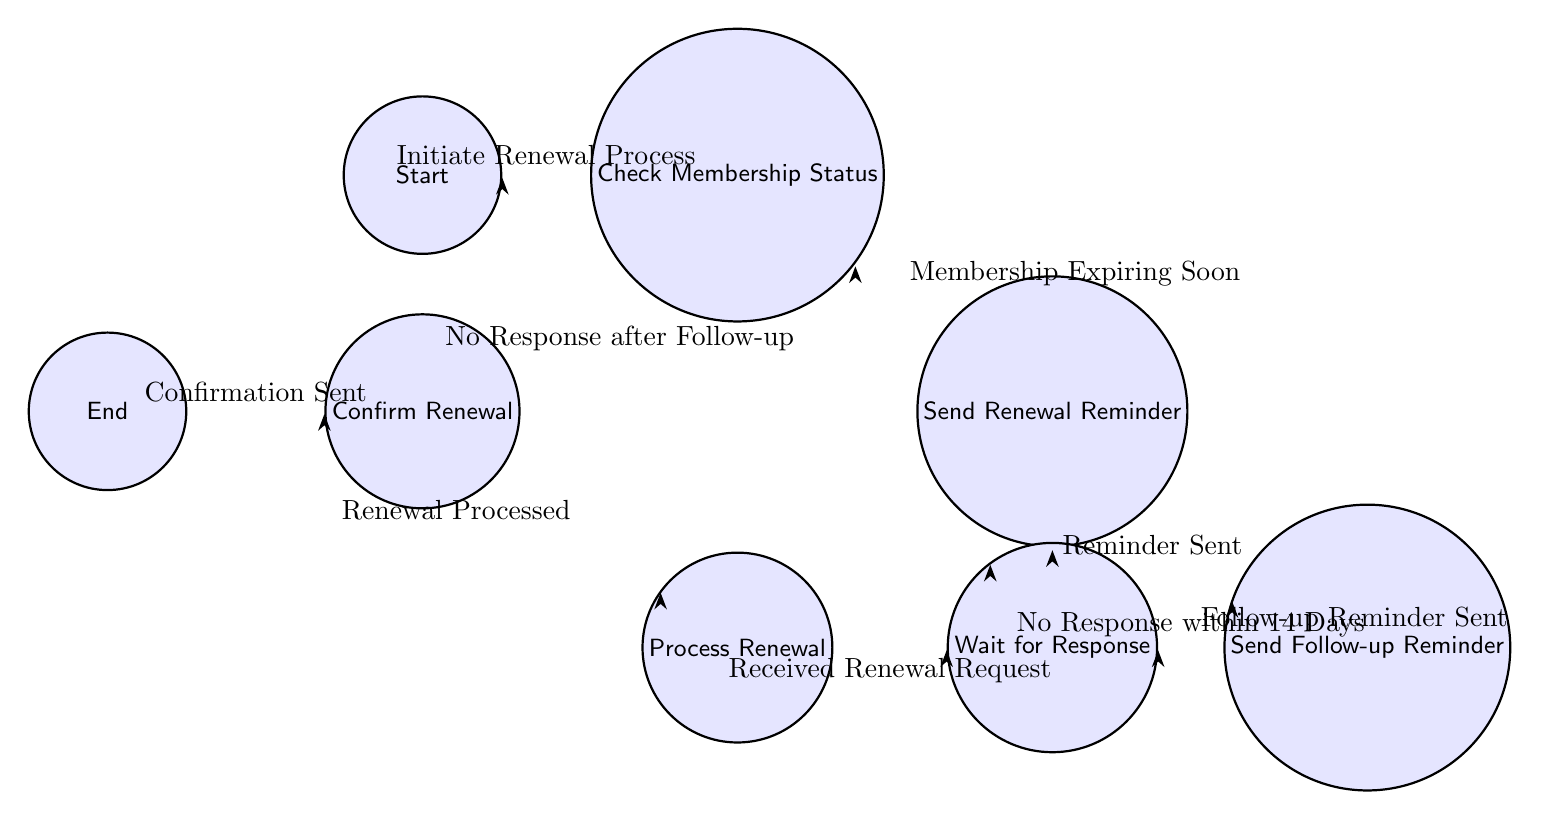What is the initial state of the membership renewal process? The initial state, represented by the first node in the diagram, is labeled “Start.”
Answer: Start How many states are present in the diagram? The diagram lists a total of eight distinct states, which can be counted on the diagram.
Answer: Eight What action leads from "Check Membership Status" to "Send Renewal Reminder"? The action listed on the edge connecting these two nodes indicates that the transition occurs when "Membership Expiring Soon."
Answer: Membership Expiring Soon What happens if no response is received within 14 days after sending the renewal reminder? Looking at the transition from “Wait for Response,” if there is no response within that time frame, the process moves to "Send Follow-up Reminder."
Answer: Send Follow-up Reminder What action is taken after processing a renewal? The next state following "Process Renewal" is "Confirm Renewal," indicating the action taken is "Renewal Processed."
Answer: Renewal Processed What is the final state after confirming a renewal? The transition from "Confirm Renewal" leads to the final state, which is "End."
Answer: End What is the path taken when a follow-up reminder is sent? The path follows from "Send Follow-up Reminder" back to "Wait for Response," indicating that another reminder was sent.
Answer: Wait for Response How many transitions involve a follow-up reminder? There are two transitions that involve a follow-up reminder: sending the initial "Send Follow-up Reminder" and transitioning back to "Wait for Response."
Answer: Two 